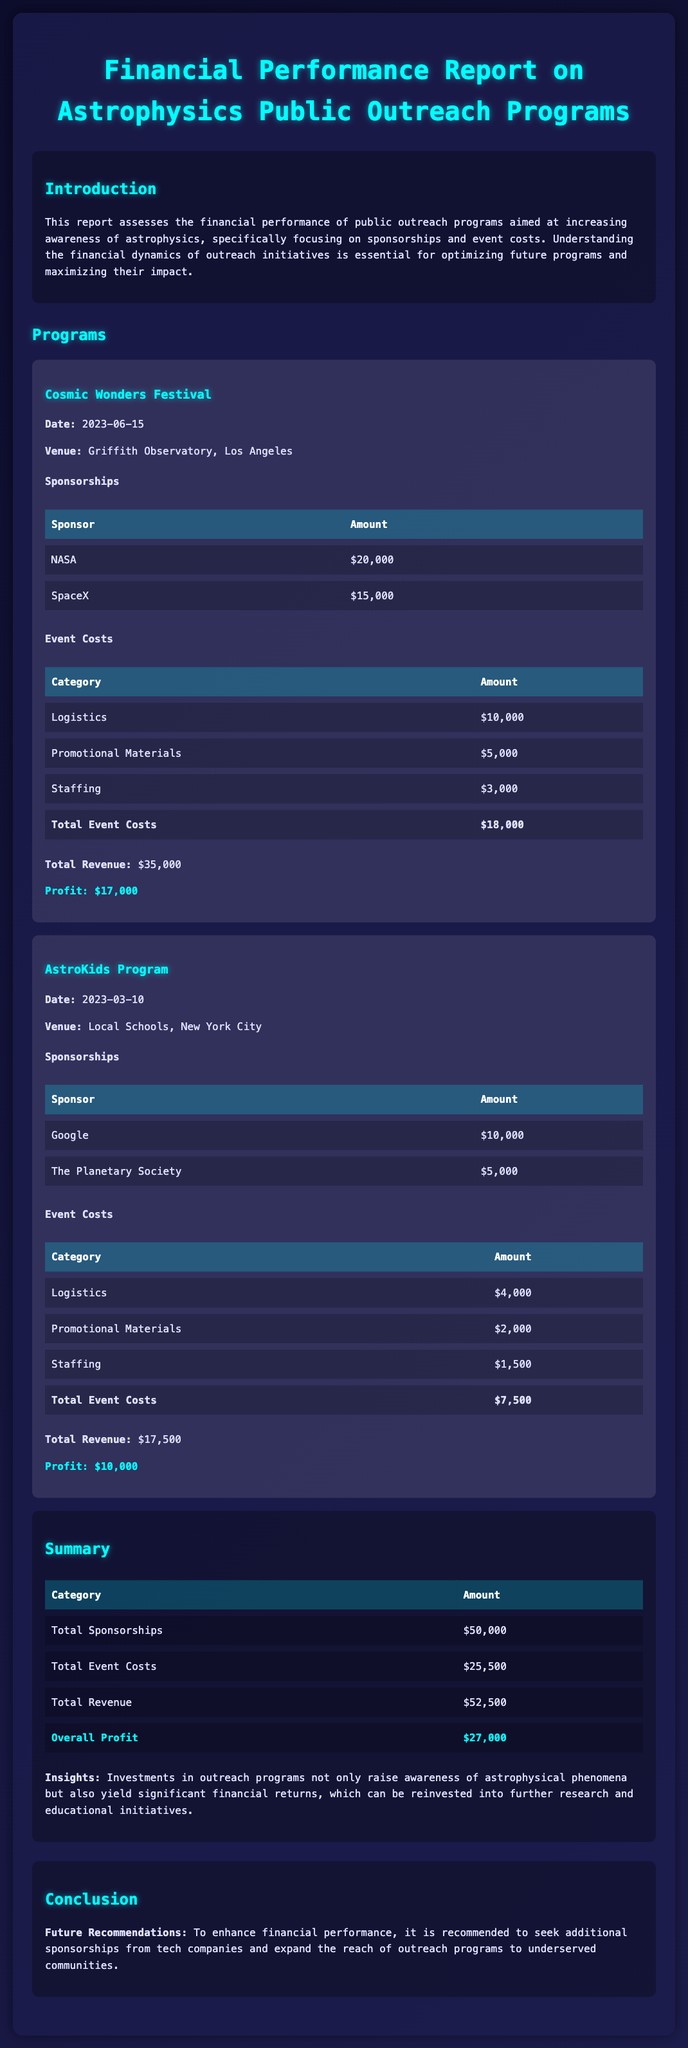what is the date of the Cosmic Wonders Festival? The date is specifically mentioned in the details of the Cosmic Wonders Festival program.
Answer: 2023-06-15 what is the total amount of sponsorships for the AstroKids Program? The total is found by adding the amounts from the sponsorships listed in the AstroKids Program details.
Answer: $15,000 what is the total revenue generated from both outreach programs? The total revenue can be calculated by summing the revenues from the Cosmic Wonders Festival and the AstroKids Program.
Answer: $52,500 what is the main recommendation for future outreach programs? The recommendation is found in the conclusion section regarding improving the financial performance of outreach.
Answer: Seek additional sponsorships what is the profit for the Cosmic Wonders Festival? The profit is stated directly after the total revenue and total event costs for that program.
Answer: $17,000 how much was spent on logistics for the AstroKids Program? The logistics cost is specifically listed in the event costs table for the AstroKids Program.
Answer: $4,000 what is the total amount spent on event costs for both programs? To find this, one can add the total event costs of both programs as indicated in the respective sections.
Answer: $25,500 what type of events are included in the outreach programs? The data presented in the programs section provides examples of the types of events held.
Answer: Festivals and school programs 